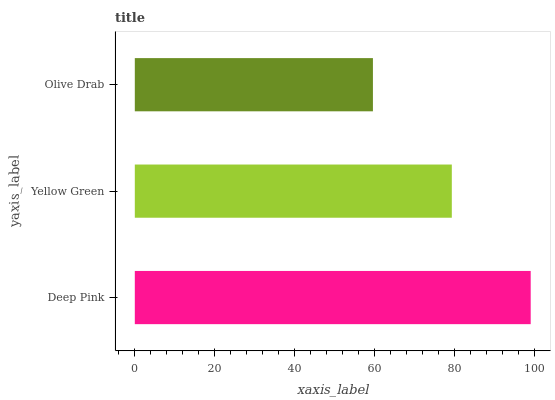Is Olive Drab the minimum?
Answer yes or no. Yes. Is Deep Pink the maximum?
Answer yes or no. Yes. Is Yellow Green the minimum?
Answer yes or no. No. Is Yellow Green the maximum?
Answer yes or no. No. Is Deep Pink greater than Yellow Green?
Answer yes or no. Yes. Is Yellow Green less than Deep Pink?
Answer yes or no. Yes. Is Yellow Green greater than Deep Pink?
Answer yes or no. No. Is Deep Pink less than Yellow Green?
Answer yes or no. No. Is Yellow Green the high median?
Answer yes or no. Yes. Is Yellow Green the low median?
Answer yes or no. Yes. Is Deep Pink the high median?
Answer yes or no. No. Is Olive Drab the low median?
Answer yes or no. No. 